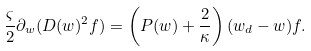<formula> <loc_0><loc_0><loc_500><loc_500>& \frac { \varsigma } { 2 } \partial _ { w } ( D ( w ) ^ { 2 } f ) = \left ( P ( w ) + \frac { 2 } { \kappa } \right ) ( w _ { d } - w ) f .</formula> 